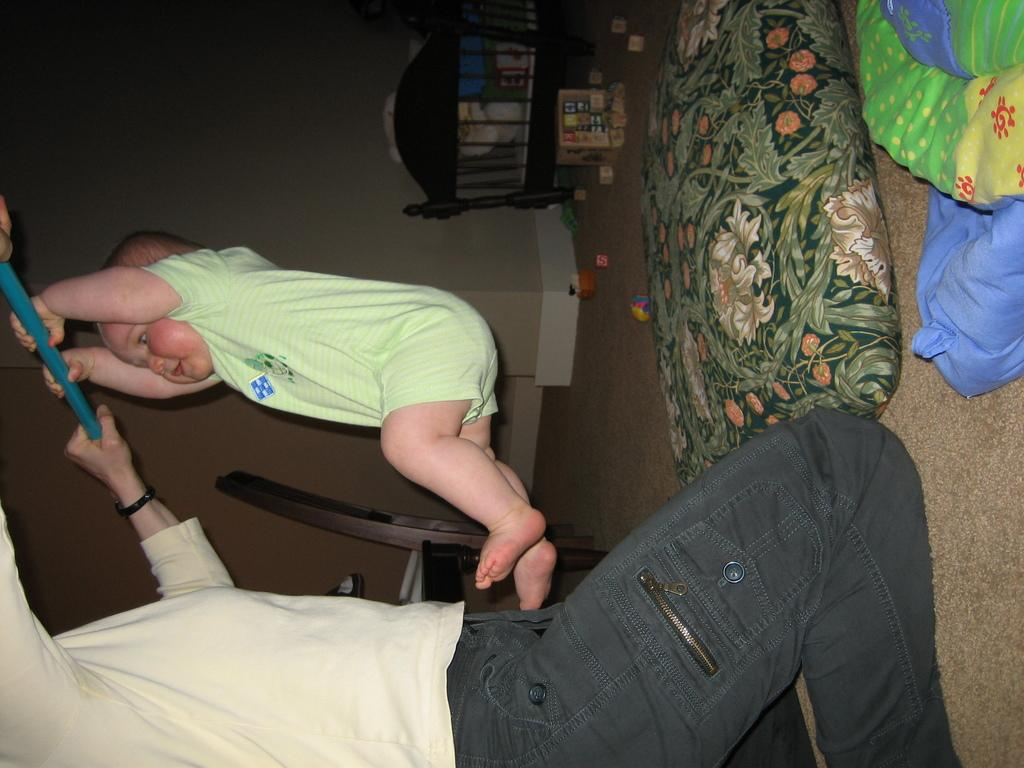Who or what can be seen in the image? There are people in the image. What is the setting or environment in the image? There is a ground with objects in the image. What type of furniture is present in the image? There is a chair in the image. What type of material is visible in the image? There is cloth and a pillow in the image. What is the structure or surface in the background of the image? There is a wall in the image. What wooden object can be seen in the image? There is a wooden object in the image. How many shoes are visible on the wall in the image? There are no shoes visible on the wall in the image. 